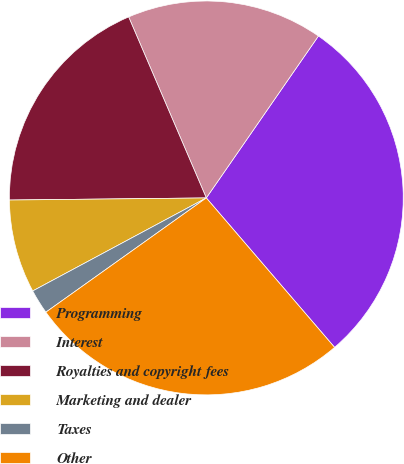Convert chart to OTSL. <chart><loc_0><loc_0><loc_500><loc_500><pie_chart><fcel>Programming<fcel>Interest<fcel>Royalties and copyright fees<fcel>Marketing and dealer<fcel>Taxes<fcel>Other<nl><fcel>29.07%<fcel>16.09%<fcel>18.72%<fcel>7.66%<fcel>2.02%<fcel>26.44%<nl></chart> 